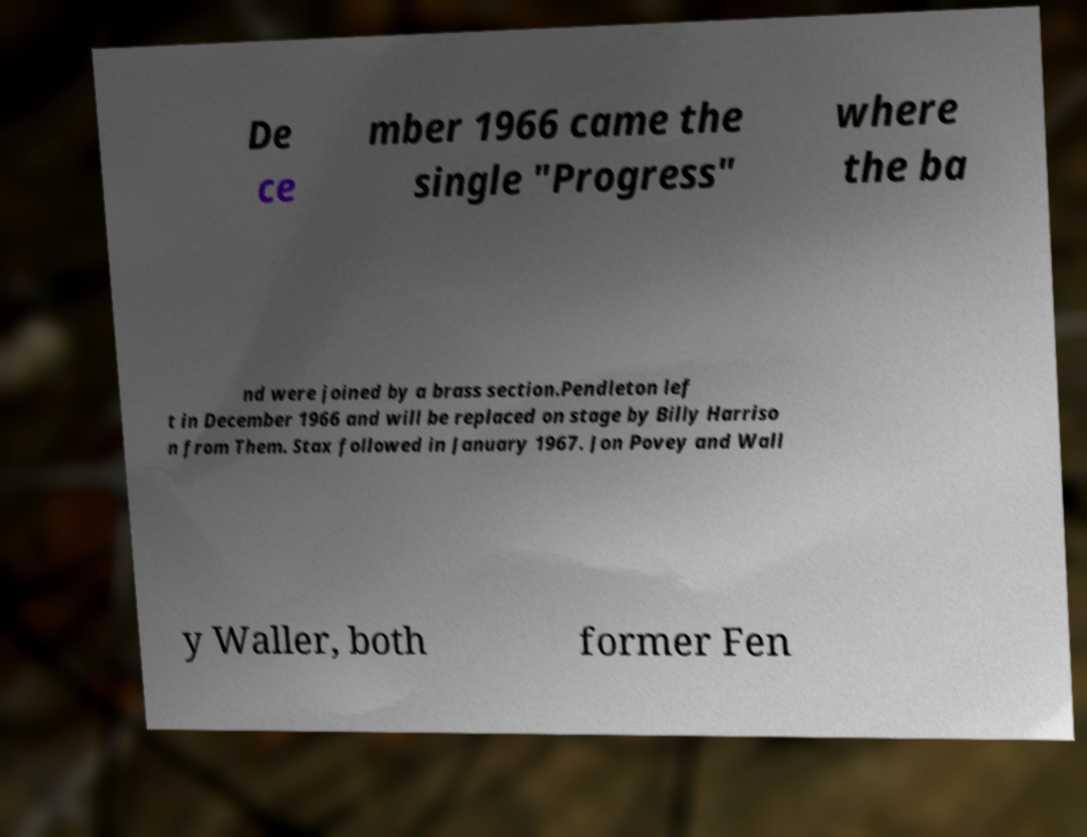Can you read and provide the text displayed in the image?This photo seems to have some interesting text. Can you extract and type it out for me? De ce mber 1966 came the single "Progress" where the ba nd were joined by a brass section.Pendleton lef t in December 1966 and will be replaced on stage by Billy Harriso n from Them. Stax followed in January 1967. Jon Povey and Wall y Waller, both former Fen 